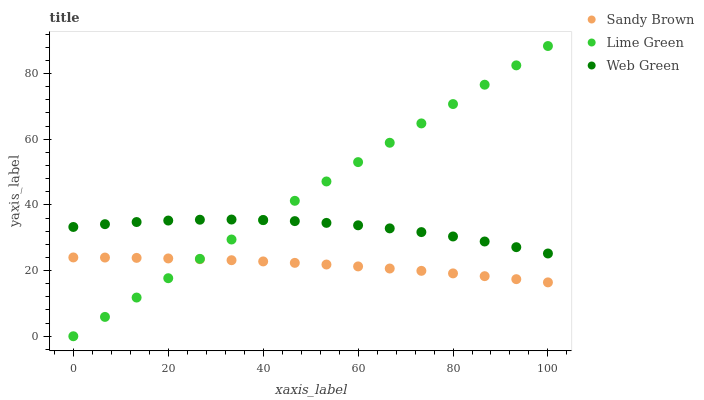Does Sandy Brown have the minimum area under the curve?
Answer yes or no. Yes. Does Lime Green have the maximum area under the curve?
Answer yes or no. Yes. Does Web Green have the minimum area under the curve?
Answer yes or no. No. Does Web Green have the maximum area under the curve?
Answer yes or no. No. Is Lime Green the smoothest?
Answer yes or no. Yes. Is Web Green the roughest?
Answer yes or no. Yes. Is Sandy Brown the smoothest?
Answer yes or no. No. Is Sandy Brown the roughest?
Answer yes or no. No. Does Lime Green have the lowest value?
Answer yes or no. Yes. Does Sandy Brown have the lowest value?
Answer yes or no. No. Does Lime Green have the highest value?
Answer yes or no. Yes. Does Web Green have the highest value?
Answer yes or no. No. Is Sandy Brown less than Web Green?
Answer yes or no. Yes. Is Web Green greater than Sandy Brown?
Answer yes or no. Yes. Does Web Green intersect Lime Green?
Answer yes or no. Yes. Is Web Green less than Lime Green?
Answer yes or no. No. Is Web Green greater than Lime Green?
Answer yes or no. No. Does Sandy Brown intersect Web Green?
Answer yes or no. No. 